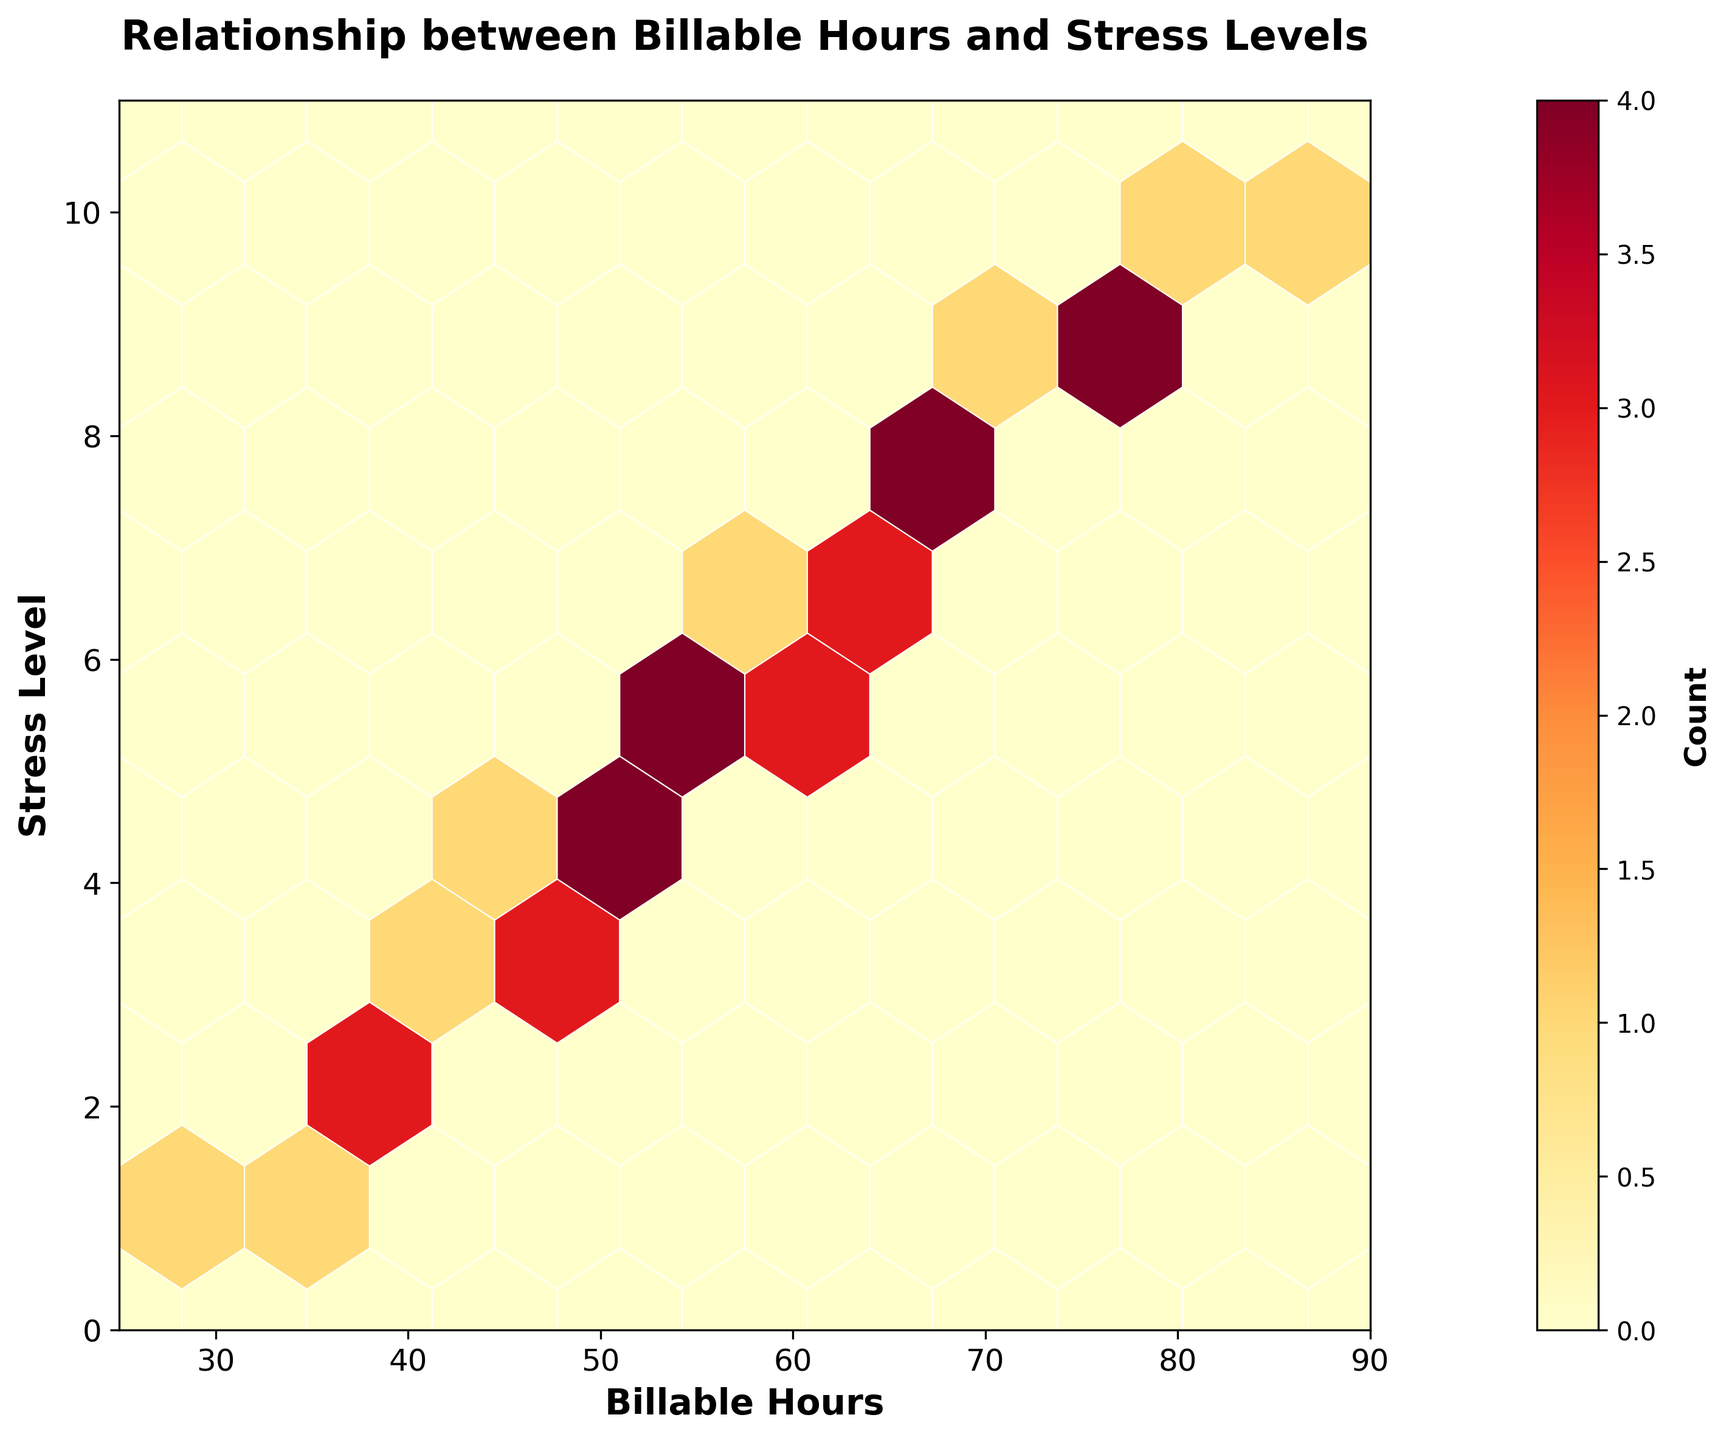How many bins are there in the hexbin plot? To determine the number of bins, count the hexagonal cells visible in the plot. This plot shows a gridsize of 10, often resulting in 10x10 = 100 hexagonal cells
Answer: 100 What color represents the highest density of data points in the plot? The color scale indicates that the color red (the darkest shade) represents the highest density of data points. This can be verified by observing the color bar on the right
Answer: Red What is the range of billable hours displayed on the x-axis? The x-axis spans from 25 to 90, as indicated by the axis labels. These labels are clearly marked at the bottom of the plot
Answer: 25 to 90 Are there more data points with stress levels between 2 and 4 or between 8 and 10? By examining the color intensity within these ranges on the y-axis, the hexagonal bins appear darker and more numerous between the stress levels of 8 and 10 than between 2 and 4
Answer: 8 and 10 Which stress level corresponds to the highest frequency of data points? The hexbin plot's darkest and most clustered hexagons indicate the highest frequency. In this case, the areas around stress levels 8 and 9 seem to have the highest density
Answer: 9 What is the color for the lowest level of data density in the plot? The color bar on the right shows that the lightest shade (yellow) corresponds to the lowest density of data points
Answer: Yellow Is there a visible correlation between billable hours and stress levels? Observing the hexbin plot, we see an upward trend as billable hours increase, stress levels also increase. This indicates a positive correlation
Answer: Yes Which range of billable hours shows the most variation in stress levels? The range of billable hours between 45 and 75 shows a wide spread of stress levels, from low to high, indicating considerable variation
Answer: 45 to 75 How many distinct stress levels are represented in the plot? Looking at the y-axis, stress levels are marked from 1 to 10. Each step is shown distinctly without gaps, representing 10 distinct stress levels
Answer: 10 At what approximate billable hours do you see the peak stress level? The hexagonal cells around 75 to 80 billable hours appear the darkest, suggesting that peak stress level data points are clustered here
Answer: 75 to 80 